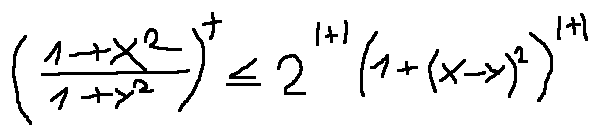Convert formula to latex. <formula><loc_0><loc_0><loc_500><loc_500>( \frac { 1 + x ^ { 2 } } { 1 + y ^ { 2 } } ) ^ { t } \leq 2 ^ { | t | } ( 1 + ( x - y ) ^ { 2 } ) ^ { | t | }</formula> 